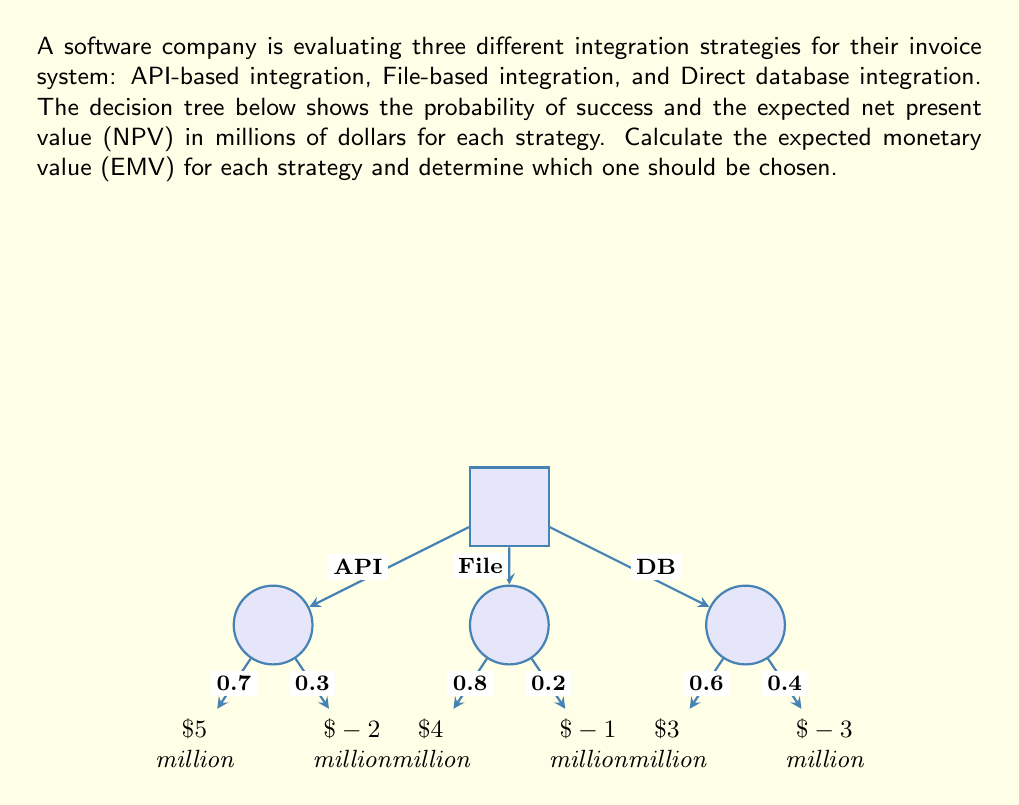Can you solve this math problem? To solve this problem, we need to calculate the Expected Monetary Value (EMV) for each integration strategy using the decision tree analysis. The EMV is the sum of each possible outcome multiplied by its probability.

1. API-based integration:
   EMV(API) = (0.7 × $5 million) + (0.3 × $-2 million)
   $$EMV(API) = (0.7 \times 5) + (0.3 \times -2) = 3.5 - 0.6 = $2.9 \text{ million}$$

2. File-based integration:
   EMV(File) = (0.8 × $4 million) + (0.2 × $-1 million)
   $$EMV(File) = (0.8 \times 4) + (0.2 \times -1) = 3.2 - 0.2 = $3.0 \text{ million}$$

3. Direct database integration:
   EMV(DB) = (0.6 × $3 million) + (0.4 × $-3 million)
   $$EMV(DB) = (0.6 \times 3) + (0.4 \times -3) = 1.8 - 1.2 = $0.6 \text{ million}$$

Now, we compare the EMV of each strategy:
API-based integration: $2.9 million
File-based integration: $3.0 million
Direct database integration: $0.6 million

The strategy with the highest EMV should be chosen, which is the File-based integration with an EMV of $3.0 million.
Answer: File-based integration ($3.0 million EMV) 